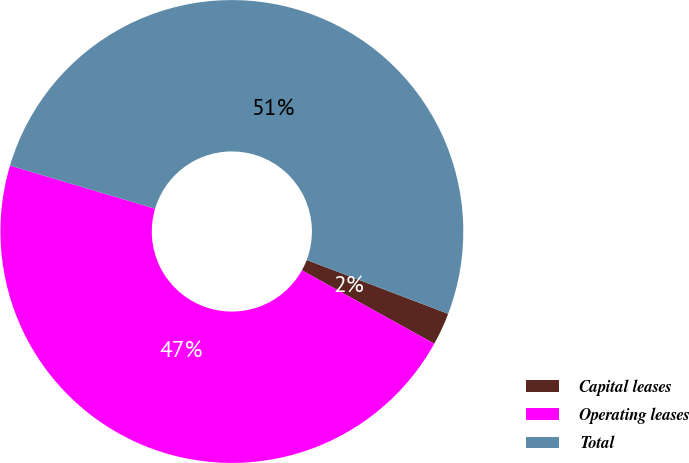<chart> <loc_0><loc_0><loc_500><loc_500><pie_chart><fcel>Capital leases<fcel>Operating leases<fcel>Total<nl><fcel>2.27%<fcel>46.54%<fcel>51.19%<nl></chart> 